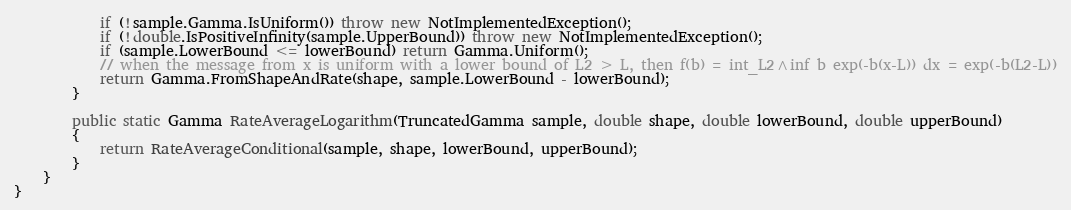Convert code to text. <code><loc_0><loc_0><loc_500><loc_500><_C#_>            if (!sample.Gamma.IsUniform()) throw new NotImplementedException();
            if (!double.IsPositiveInfinity(sample.UpperBound)) throw new NotImplementedException();
            if (sample.LowerBound <= lowerBound) return Gamma.Uniform();
            // when the message from x is uniform with a lower bound of L2 > L, then f(b) = int_L2^inf b exp(-b(x-L)) dx = exp(-b(L2-L))
            return Gamma.FromShapeAndRate(shape, sample.LowerBound - lowerBound);
        }

        public static Gamma RateAverageLogarithm(TruncatedGamma sample, double shape, double lowerBound, double upperBound)
        {
            return RateAverageConditional(sample, shape, lowerBound, upperBound);
        }
    }
}
</code> 